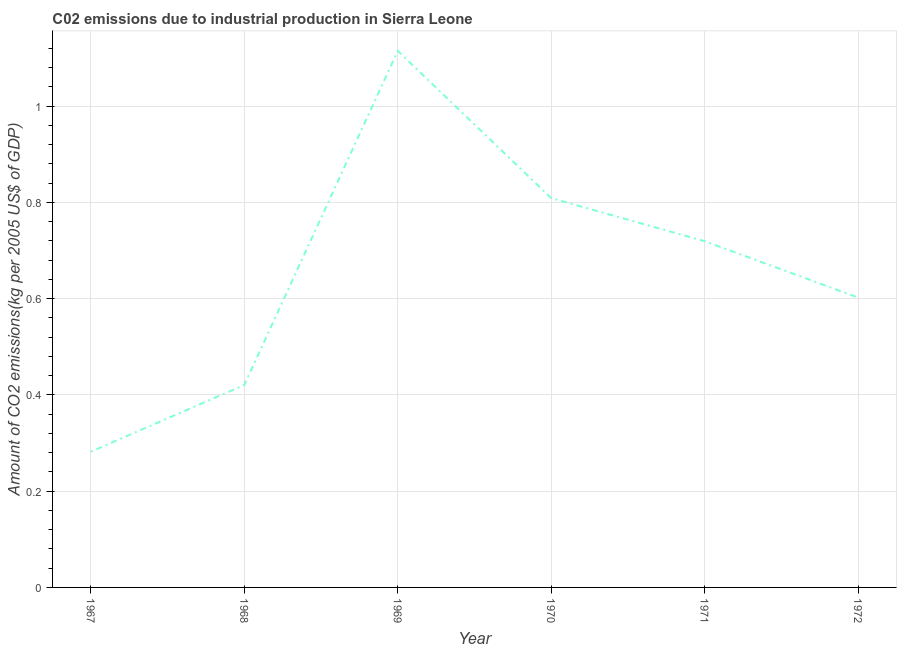What is the amount of co2 emissions in 1967?
Keep it short and to the point. 0.28. Across all years, what is the maximum amount of co2 emissions?
Ensure brevity in your answer.  1.11. Across all years, what is the minimum amount of co2 emissions?
Keep it short and to the point. 0.28. In which year was the amount of co2 emissions maximum?
Offer a terse response. 1969. In which year was the amount of co2 emissions minimum?
Provide a short and direct response. 1967. What is the sum of the amount of co2 emissions?
Offer a terse response. 3.95. What is the difference between the amount of co2 emissions in 1970 and 1971?
Give a very brief answer. 0.09. What is the average amount of co2 emissions per year?
Make the answer very short. 0.66. What is the median amount of co2 emissions?
Make the answer very short. 0.66. Do a majority of the years between 1968 and 1970 (inclusive) have amount of co2 emissions greater than 0.08 kg per 2005 US$ of GDP?
Provide a succinct answer. Yes. What is the ratio of the amount of co2 emissions in 1967 to that in 1972?
Offer a very short reply. 0.47. What is the difference between the highest and the second highest amount of co2 emissions?
Keep it short and to the point. 0.31. Is the sum of the amount of co2 emissions in 1967 and 1971 greater than the maximum amount of co2 emissions across all years?
Keep it short and to the point. No. What is the difference between the highest and the lowest amount of co2 emissions?
Your response must be concise. 0.83. In how many years, is the amount of co2 emissions greater than the average amount of co2 emissions taken over all years?
Your response must be concise. 3. Does the amount of co2 emissions monotonically increase over the years?
Give a very brief answer. No. How many years are there in the graph?
Offer a very short reply. 6. What is the difference between two consecutive major ticks on the Y-axis?
Your response must be concise. 0.2. Are the values on the major ticks of Y-axis written in scientific E-notation?
Make the answer very short. No. Does the graph contain any zero values?
Your answer should be compact. No. Does the graph contain grids?
Give a very brief answer. Yes. What is the title of the graph?
Offer a very short reply. C02 emissions due to industrial production in Sierra Leone. What is the label or title of the X-axis?
Keep it short and to the point. Year. What is the label or title of the Y-axis?
Keep it short and to the point. Amount of CO2 emissions(kg per 2005 US$ of GDP). What is the Amount of CO2 emissions(kg per 2005 US$ of GDP) of 1967?
Give a very brief answer. 0.28. What is the Amount of CO2 emissions(kg per 2005 US$ of GDP) in 1968?
Your response must be concise. 0.42. What is the Amount of CO2 emissions(kg per 2005 US$ of GDP) of 1969?
Your answer should be very brief. 1.11. What is the Amount of CO2 emissions(kg per 2005 US$ of GDP) in 1970?
Offer a very short reply. 0.81. What is the Amount of CO2 emissions(kg per 2005 US$ of GDP) of 1971?
Provide a short and direct response. 0.72. What is the Amount of CO2 emissions(kg per 2005 US$ of GDP) in 1972?
Offer a terse response. 0.6. What is the difference between the Amount of CO2 emissions(kg per 2005 US$ of GDP) in 1967 and 1968?
Your answer should be compact. -0.14. What is the difference between the Amount of CO2 emissions(kg per 2005 US$ of GDP) in 1967 and 1969?
Offer a terse response. -0.83. What is the difference between the Amount of CO2 emissions(kg per 2005 US$ of GDP) in 1967 and 1970?
Keep it short and to the point. -0.53. What is the difference between the Amount of CO2 emissions(kg per 2005 US$ of GDP) in 1967 and 1971?
Give a very brief answer. -0.44. What is the difference between the Amount of CO2 emissions(kg per 2005 US$ of GDP) in 1967 and 1972?
Offer a terse response. -0.32. What is the difference between the Amount of CO2 emissions(kg per 2005 US$ of GDP) in 1968 and 1969?
Your answer should be very brief. -0.69. What is the difference between the Amount of CO2 emissions(kg per 2005 US$ of GDP) in 1968 and 1970?
Offer a terse response. -0.39. What is the difference between the Amount of CO2 emissions(kg per 2005 US$ of GDP) in 1968 and 1971?
Offer a very short reply. -0.3. What is the difference between the Amount of CO2 emissions(kg per 2005 US$ of GDP) in 1968 and 1972?
Provide a short and direct response. -0.18. What is the difference between the Amount of CO2 emissions(kg per 2005 US$ of GDP) in 1969 and 1970?
Provide a succinct answer. 0.31. What is the difference between the Amount of CO2 emissions(kg per 2005 US$ of GDP) in 1969 and 1971?
Provide a succinct answer. 0.4. What is the difference between the Amount of CO2 emissions(kg per 2005 US$ of GDP) in 1969 and 1972?
Your answer should be very brief. 0.51. What is the difference between the Amount of CO2 emissions(kg per 2005 US$ of GDP) in 1970 and 1971?
Make the answer very short. 0.09. What is the difference between the Amount of CO2 emissions(kg per 2005 US$ of GDP) in 1970 and 1972?
Ensure brevity in your answer.  0.21. What is the difference between the Amount of CO2 emissions(kg per 2005 US$ of GDP) in 1971 and 1972?
Offer a very short reply. 0.12. What is the ratio of the Amount of CO2 emissions(kg per 2005 US$ of GDP) in 1967 to that in 1968?
Ensure brevity in your answer.  0.67. What is the ratio of the Amount of CO2 emissions(kg per 2005 US$ of GDP) in 1967 to that in 1969?
Keep it short and to the point. 0.25. What is the ratio of the Amount of CO2 emissions(kg per 2005 US$ of GDP) in 1967 to that in 1970?
Offer a very short reply. 0.35. What is the ratio of the Amount of CO2 emissions(kg per 2005 US$ of GDP) in 1967 to that in 1971?
Provide a succinct answer. 0.39. What is the ratio of the Amount of CO2 emissions(kg per 2005 US$ of GDP) in 1967 to that in 1972?
Your answer should be compact. 0.47. What is the ratio of the Amount of CO2 emissions(kg per 2005 US$ of GDP) in 1968 to that in 1969?
Offer a terse response. 0.38. What is the ratio of the Amount of CO2 emissions(kg per 2005 US$ of GDP) in 1968 to that in 1970?
Ensure brevity in your answer.  0.52. What is the ratio of the Amount of CO2 emissions(kg per 2005 US$ of GDP) in 1968 to that in 1971?
Offer a terse response. 0.58. What is the ratio of the Amount of CO2 emissions(kg per 2005 US$ of GDP) in 1968 to that in 1972?
Ensure brevity in your answer.  0.7. What is the ratio of the Amount of CO2 emissions(kg per 2005 US$ of GDP) in 1969 to that in 1970?
Provide a succinct answer. 1.38. What is the ratio of the Amount of CO2 emissions(kg per 2005 US$ of GDP) in 1969 to that in 1971?
Your answer should be very brief. 1.55. What is the ratio of the Amount of CO2 emissions(kg per 2005 US$ of GDP) in 1969 to that in 1972?
Your response must be concise. 1.85. What is the ratio of the Amount of CO2 emissions(kg per 2005 US$ of GDP) in 1970 to that in 1971?
Make the answer very short. 1.12. What is the ratio of the Amount of CO2 emissions(kg per 2005 US$ of GDP) in 1970 to that in 1972?
Provide a succinct answer. 1.34. What is the ratio of the Amount of CO2 emissions(kg per 2005 US$ of GDP) in 1971 to that in 1972?
Your response must be concise. 1.19. 